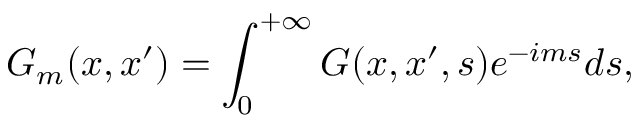<formula> <loc_0><loc_0><loc_500><loc_500>G _ { m } ( x , x ^ { \prime } ) = \int _ { 0 } ^ { + \infty } G ( x , x ^ { \prime } , s ) e ^ { - i m s } d s ,</formula> 